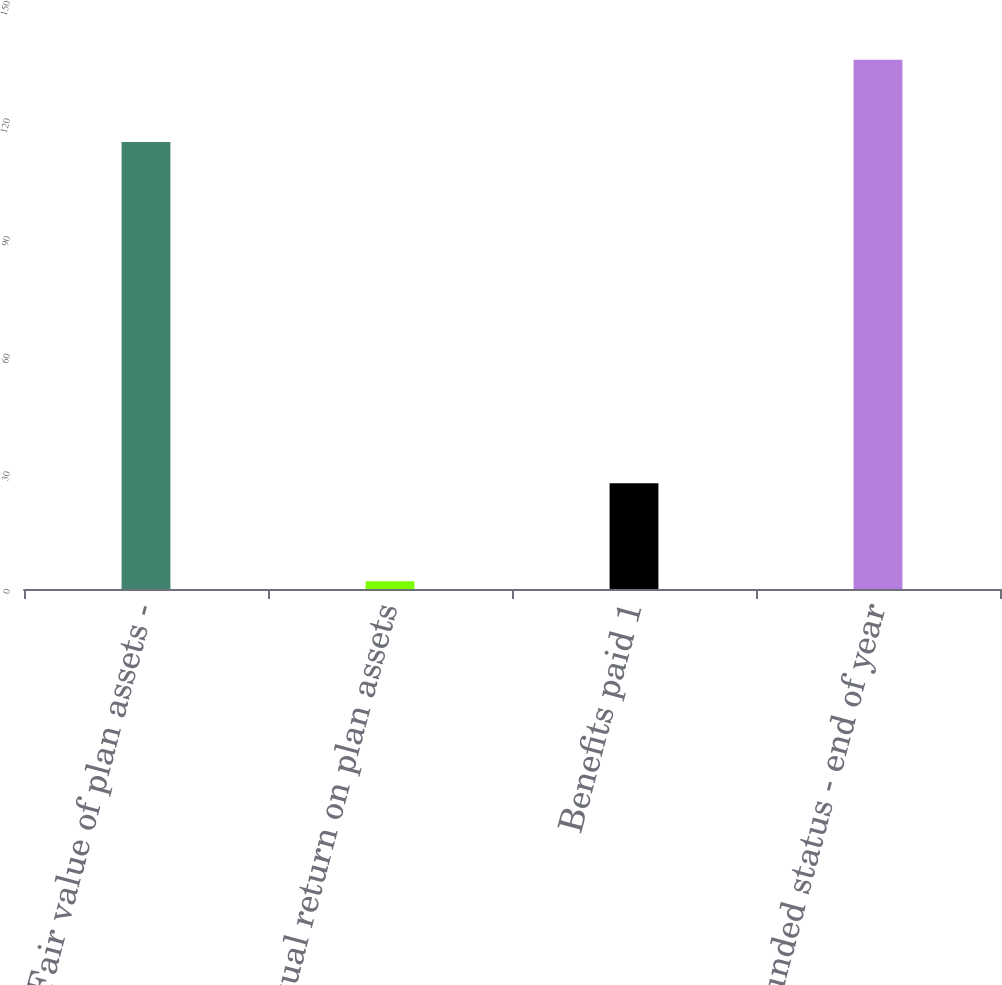<chart> <loc_0><loc_0><loc_500><loc_500><bar_chart><fcel>Fair value of plan assets -<fcel>Actual return on plan assets<fcel>Benefits paid 1<fcel>Funded status - end of year<nl><fcel>114<fcel>2<fcel>27<fcel>135<nl></chart> 